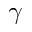Convert formula to latex. <formula><loc_0><loc_0><loc_500><loc_500>\gamma</formula> 